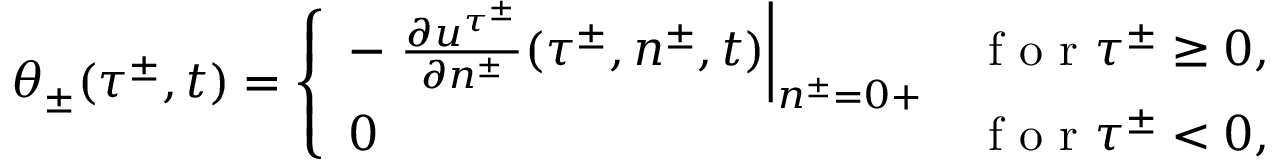<formula> <loc_0><loc_0><loc_500><loc_500>\theta _ { \pm } ( \tau ^ { \pm } , t ) = \left \{ \begin{array} { l l } { - \frac { \partial u ^ { \tau ^ { \pm } } } { \partial n ^ { \pm } } ( \tau ^ { \pm } , n ^ { \pm } , t ) \right | _ { n ^ { \pm } = 0 + } } & { f o r \tau ^ { \pm } \geq 0 , } \\ { 0 } & { f o r \tau ^ { \pm } < 0 , } \end{array}</formula> 